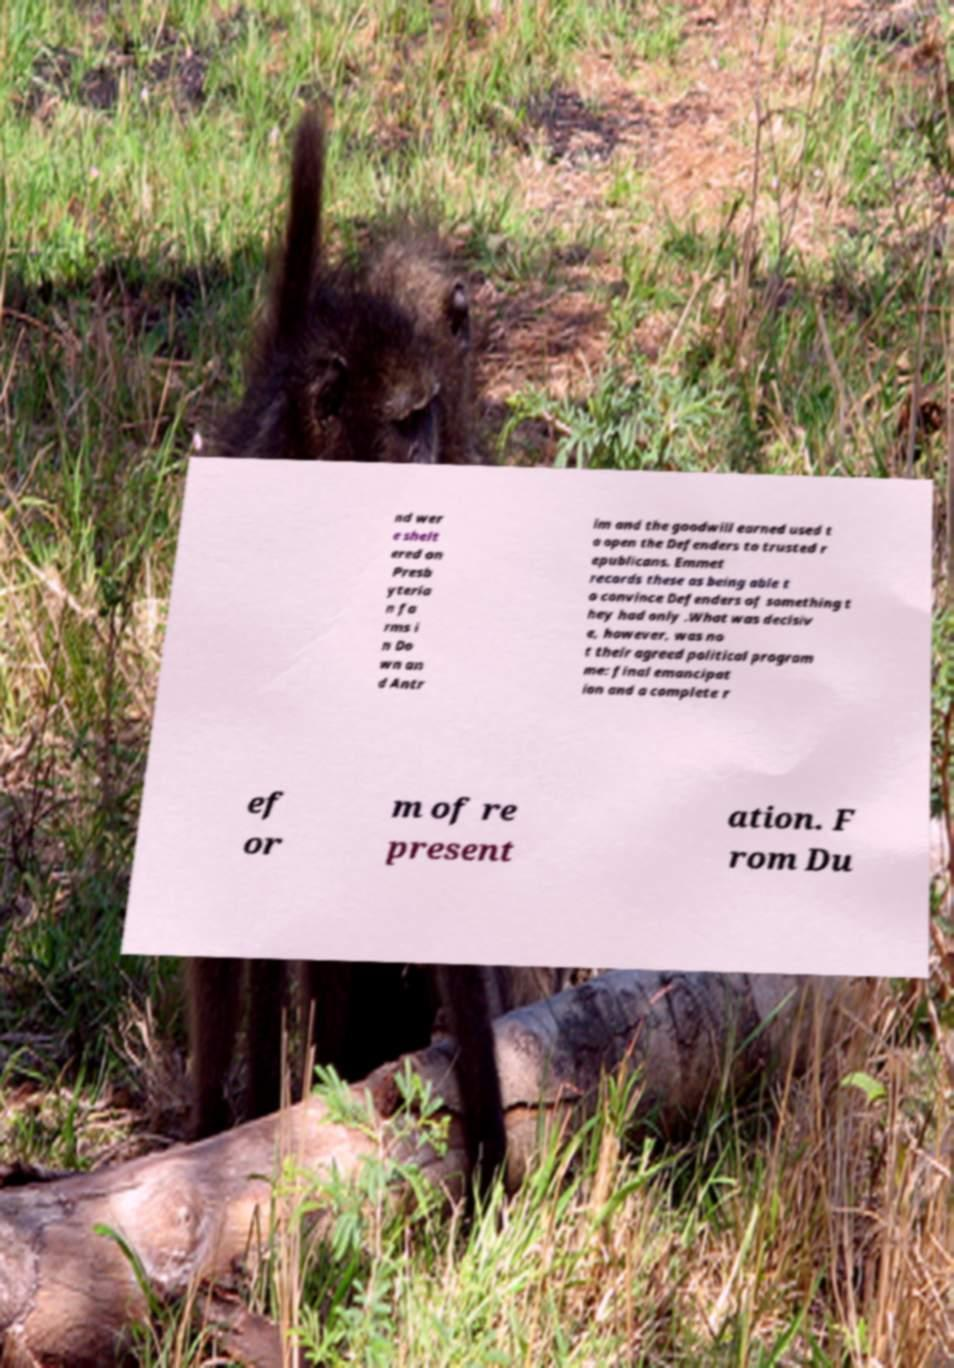What messages or text are displayed in this image? I need them in a readable, typed format. nd wer e shelt ered on Presb yteria n fa rms i n Do wn an d Antr im and the goodwill earned used t o open the Defenders to trusted r epublicans. Emmet records these as being able t o convince Defenders of something t hey had only .What was decisiv e, however, was no t their agreed political program me: final emancipat ion and a complete r ef or m of re present ation. F rom Du 